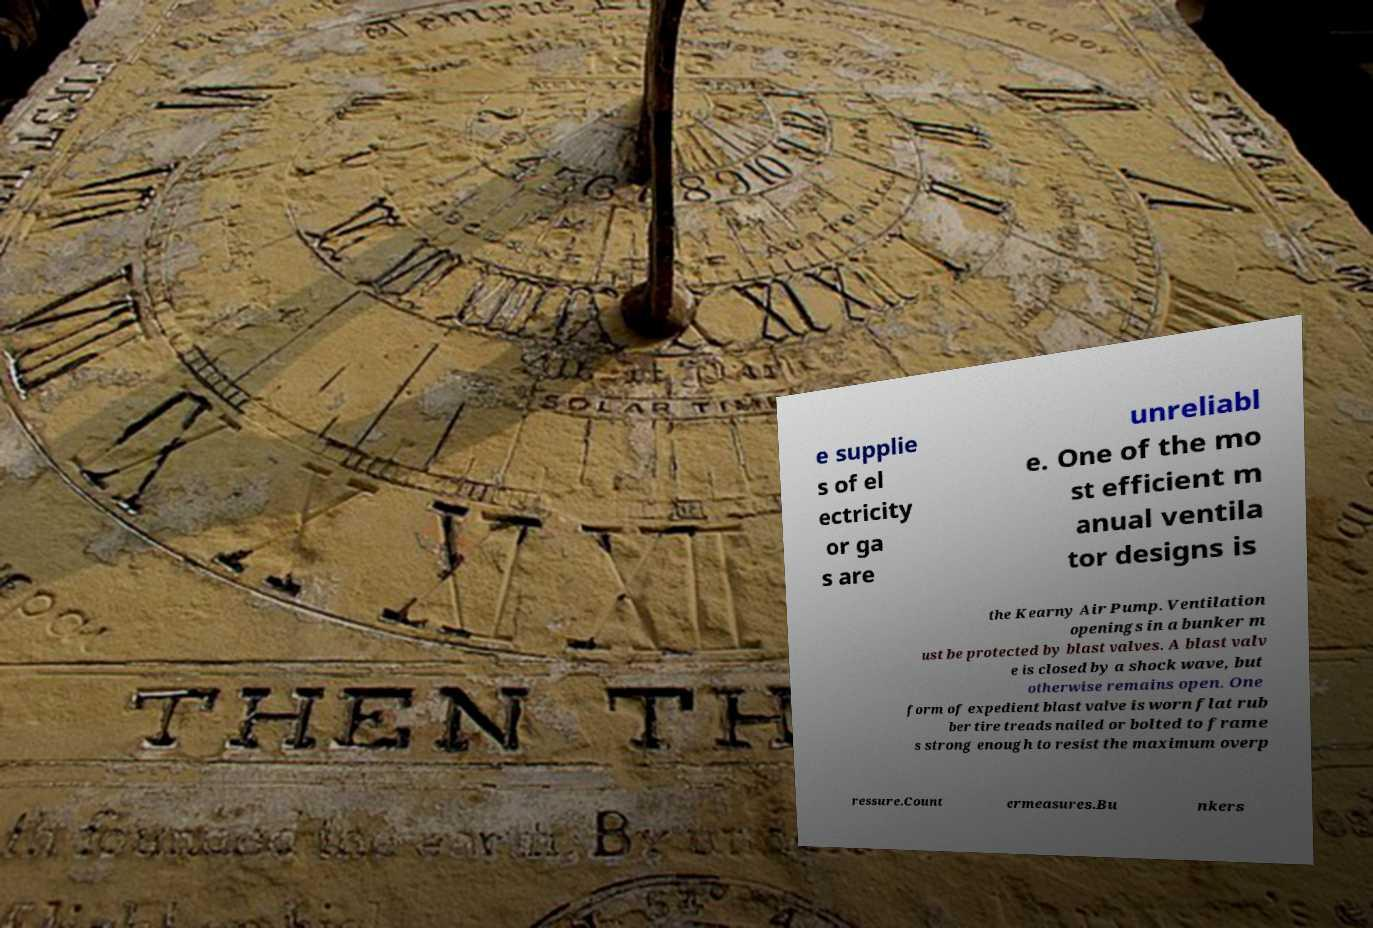Could you extract and type out the text from this image? e supplie s of el ectricity or ga s are unreliabl e. One of the mo st efficient m anual ventila tor designs is the Kearny Air Pump. Ventilation openings in a bunker m ust be protected by blast valves. A blast valv e is closed by a shock wave, but otherwise remains open. One form of expedient blast valve is worn flat rub ber tire treads nailed or bolted to frame s strong enough to resist the maximum overp ressure.Count ermeasures.Bu nkers 